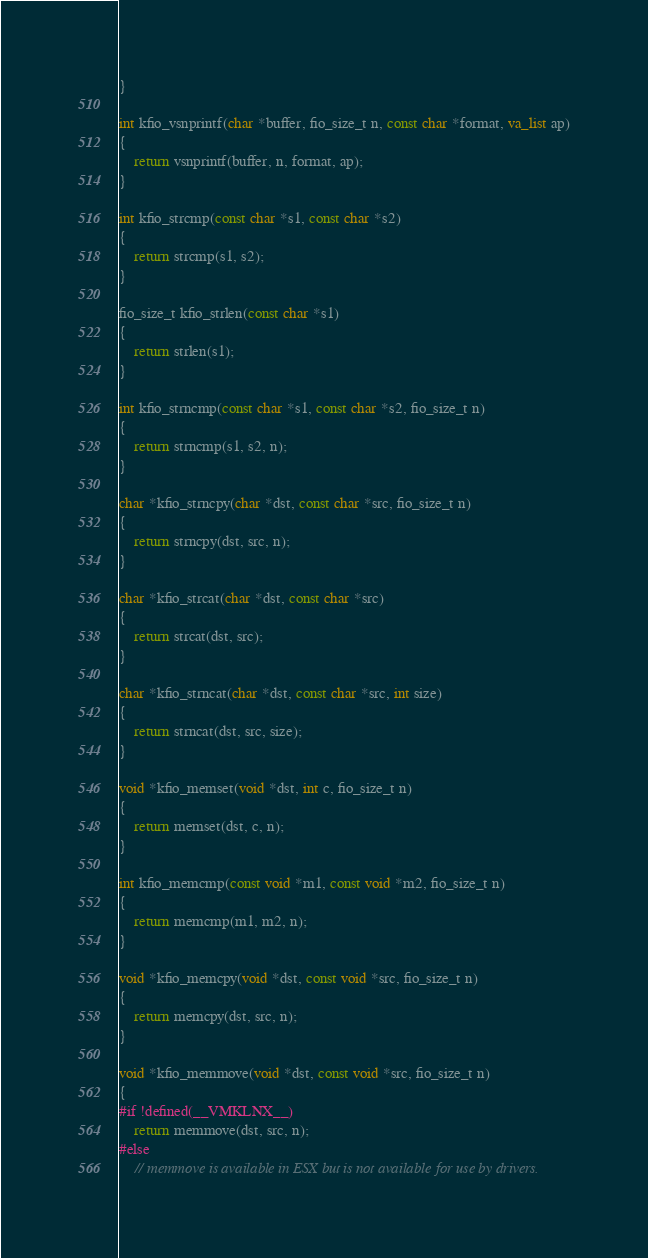Convert code to text. <code><loc_0><loc_0><loc_500><loc_500><_C_>}

int kfio_vsnprintf(char *buffer, fio_size_t n, const char *format, va_list ap)
{
    return vsnprintf(buffer, n, format, ap);
}

int kfio_strcmp(const char *s1, const char *s2)
{
    return strcmp(s1, s2);
}

fio_size_t kfio_strlen(const char *s1)
{
    return strlen(s1);
}

int kfio_strncmp(const char *s1, const char *s2, fio_size_t n)
{
    return strncmp(s1, s2, n);
}

char *kfio_strncpy(char *dst, const char *src, fio_size_t n)
{
    return strncpy(dst, src, n);
}

char *kfio_strcat(char *dst, const char *src)
{
    return strcat(dst, src);
}

char *kfio_strncat(char *dst, const char *src, int size)
{
    return strncat(dst, src, size);
}

void *kfio_memset(void *dst, int c, fio_size_t n)
{
    return memset(dst, c, n);
}

int kfio_memcmp(const void *m1, const void *m2, fio_size_t n)
{
    return memcmp(m1, m2, n);
}

void *kfio_memcpy(void *dst, const void *src, fio_size_t n)
{
    return memcpy(dst, src, n);
}

void *kfio_memmove(void *dst, const void *src, fio_size_t n)
{
#if !defined(__VMKLNX__)
    return memmove(dst, src, n);
#else
    // memmove is available in ESX but is not available for use by drivers.</code> 